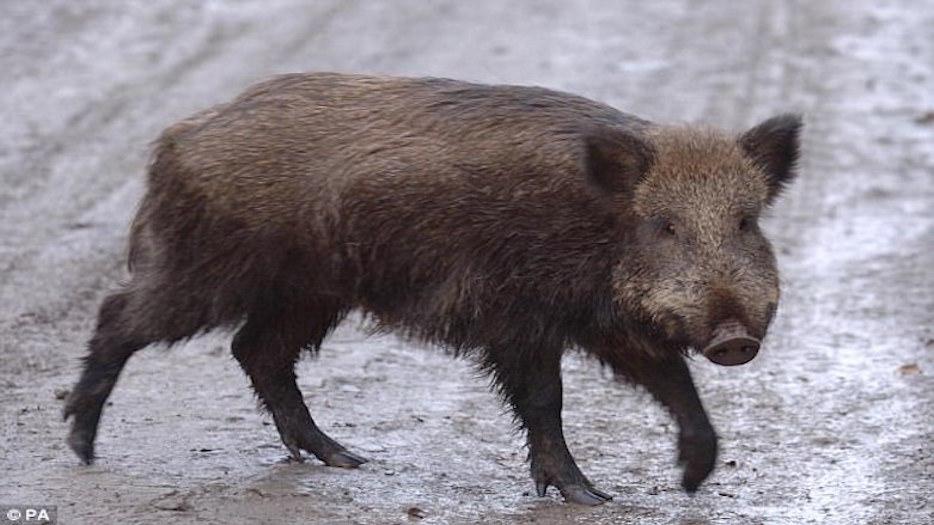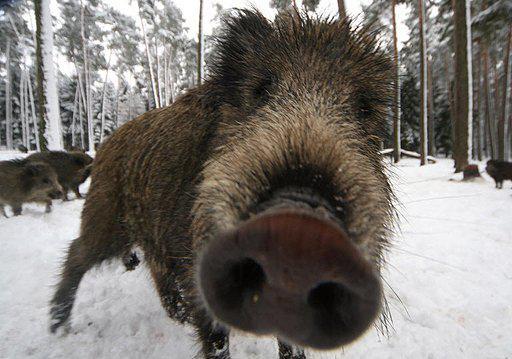The first image is the image on the left, the second image is the image on the right. Assess this claim about the two images: "There are at most 3 hogs total.". Correct or not? Answer yes or no. No. 